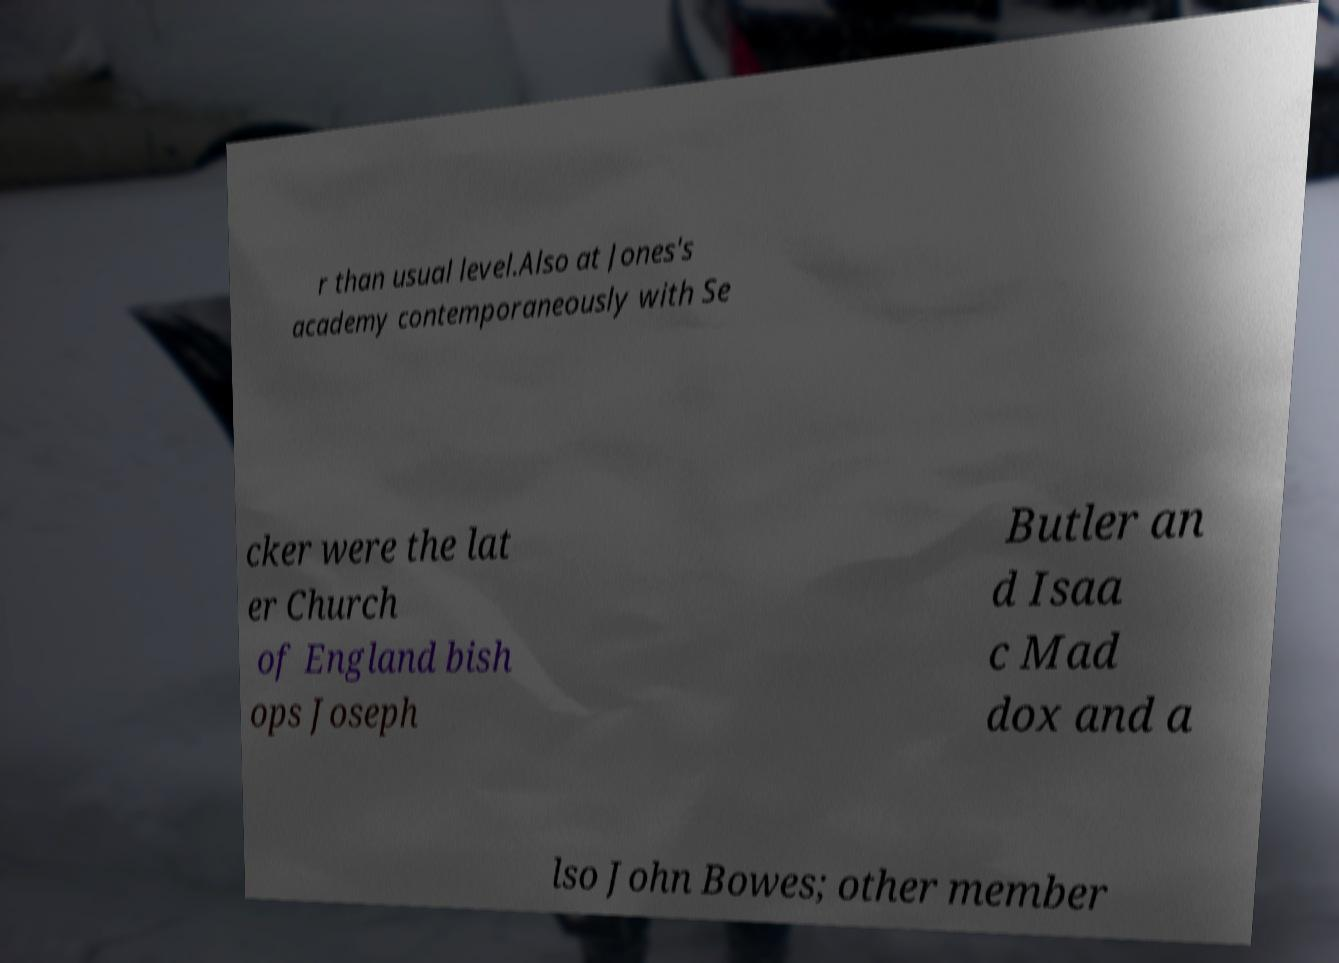Can you accurately transcribe the text from the provided image for me? r than usual level.Also at Jones's academy contemporaneously with Se cker were the lat er Church of England bish ops Joseph Butler an d Isaa c Mad dox and a lso John Bowes; other member 